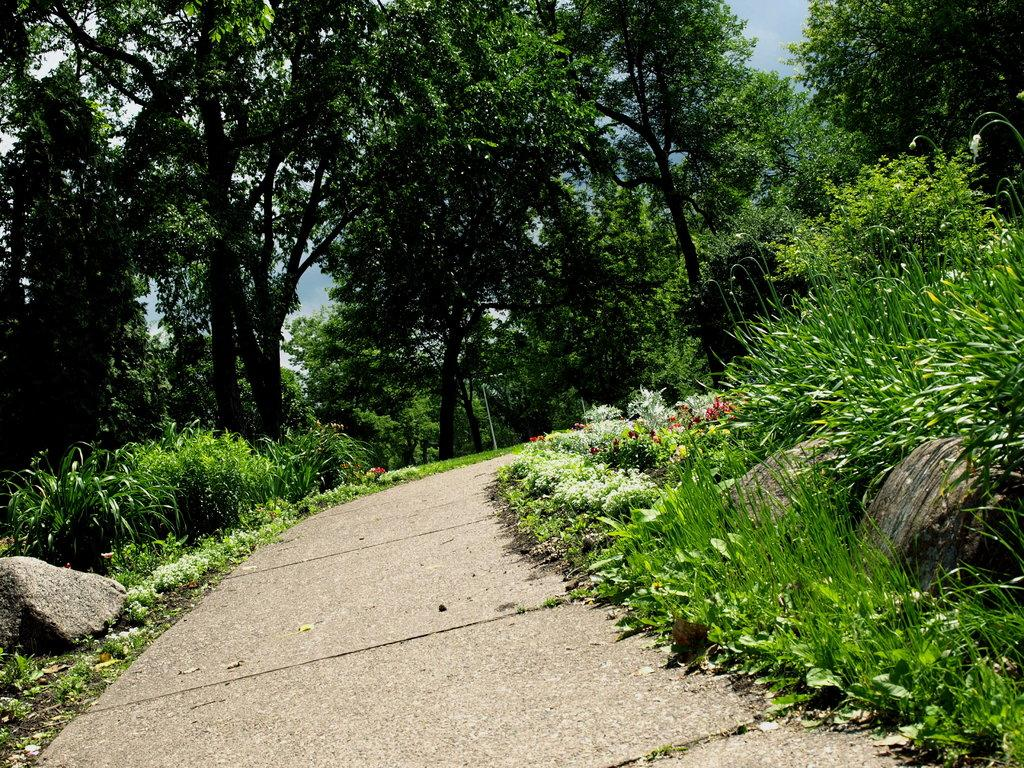What can be seen in the foreground of the image? There is a pathway in the image. What is visible in the background of the image? Plants, trees, and the sky are visible in the background of the image. What is the color of the plants in the image? The plants are green in color. What is the color of the trees in the image? The trees are green in color. What is the color of the sky in the image? The sky is blue in color. How many girls are wearing dresses in the image? There are no girls or dresses present in the image. 